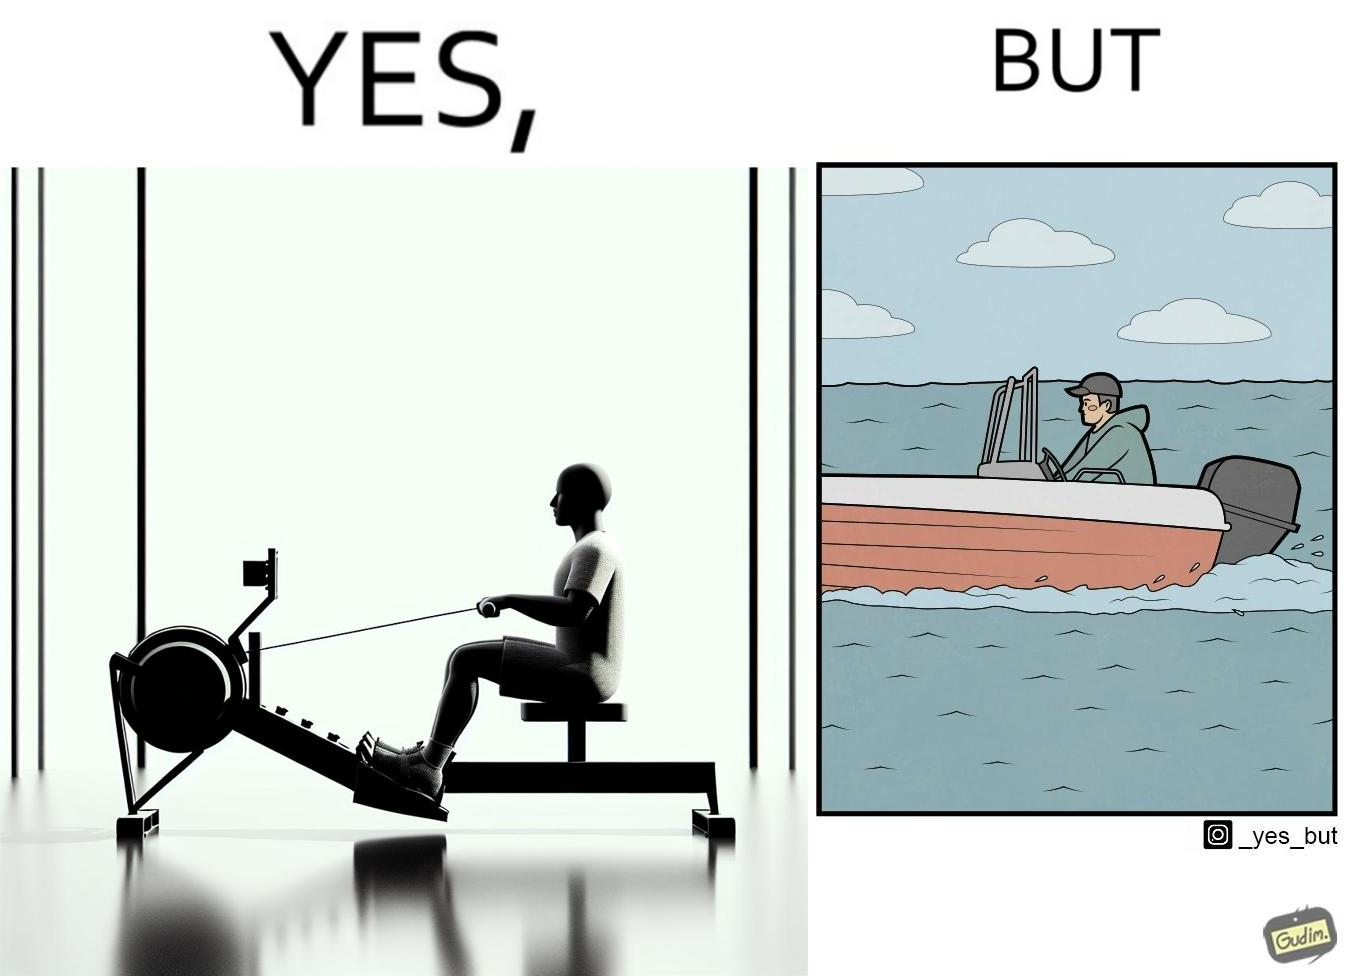Why is this image considered satirical? The image is ironic, because people often use rowing machine at the gym don't prefer rowing when it comes to boats 